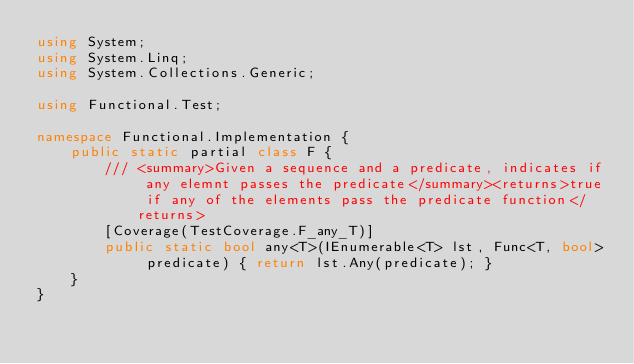<code> <loc_0><loc_0><loc_500><loc_500><_C#_>using System;
using System.Linq;
using System.Collections.Generic;

using Functional.Test;

namespace Functional.Implementation {
    public static partial class F {
        /// <summary>Given a sequence and a predicate, indicates if any elemnt passes the predicate</summary><returns>true if any of the elements pass the predicate function</returns>
        [Coverage(TestCoverage.F_any_T)]
        public static bool any<T>(IEnumerable<T> lst, Func<T, bool> predicate) { return lst.Any(predicate); }
    }
}</code> 